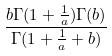Convert formula to latex. <formula><loc_0><loc_0><loc_500><loc_500>\frac { b \Gamma ( 1 + \frac { 1 } { a } ) \Gamma ( b ) } { \Gamma ( 1 + \frac { 1 } { a } + b ) }</formula> 